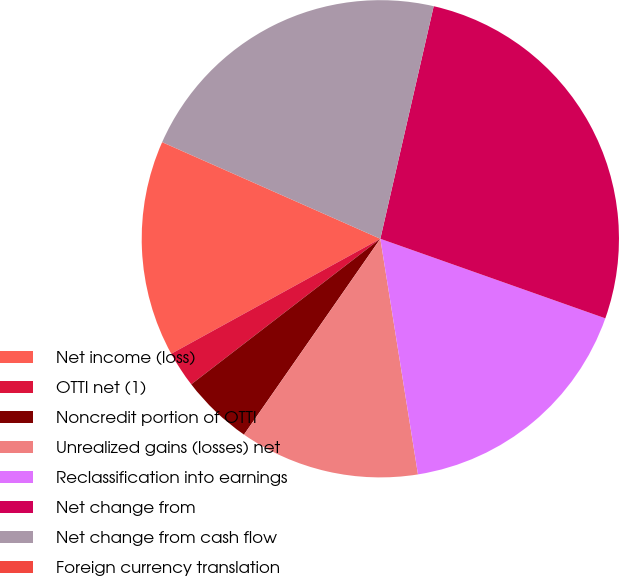<chart> <loc_0><loc_0><loc_500><loc_500><pie_chart><fcel>Net income (loss)<fcel>OTTI net (1)<fcel>Noncredit portion of OTTI<fcel>Unrealized gains (losses) net<fcel>Reclassification into earnings<fcel>Net change from<fcel>Net change from cash flow<fcel>Foreign currency translation<nl><fcel>14.63%<fcel>2.44%<fcel>4.88%<fcel>12.2%<fcel>17.07%<fcel>26.82%<fcel>21.95%<fcel>0.01%<nl></chart> 